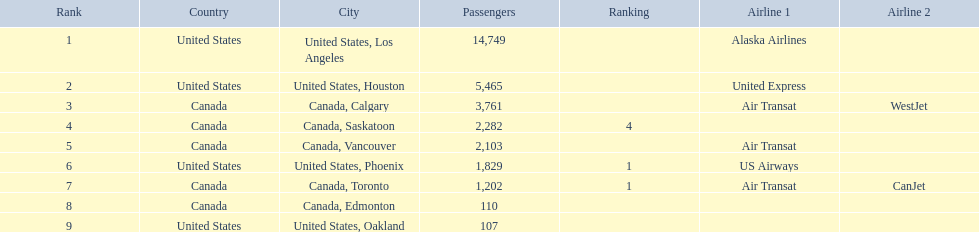What is the average number of passengers in the united states? 5537.5. 